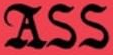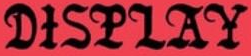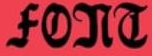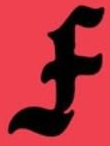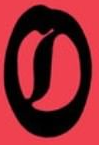What words are shown in these images in order, separated by a semicolon? ASS; DISPLAY; FONT; F; O 